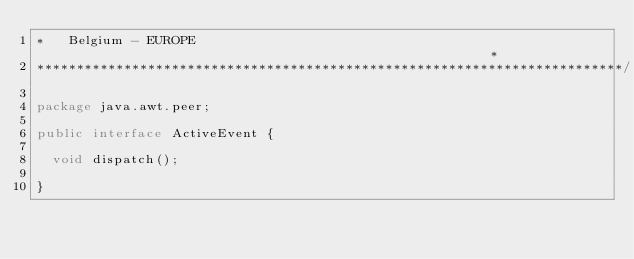Convert code to text. <code><loc_0><loc_0><loc_500><loc_500><_Java_>*   Belgium - EUROPE                                                      *
**************************************************************************/

package java.awt.peer;

public interface ActiveEvent {

  void dispatch();

}

</code> 